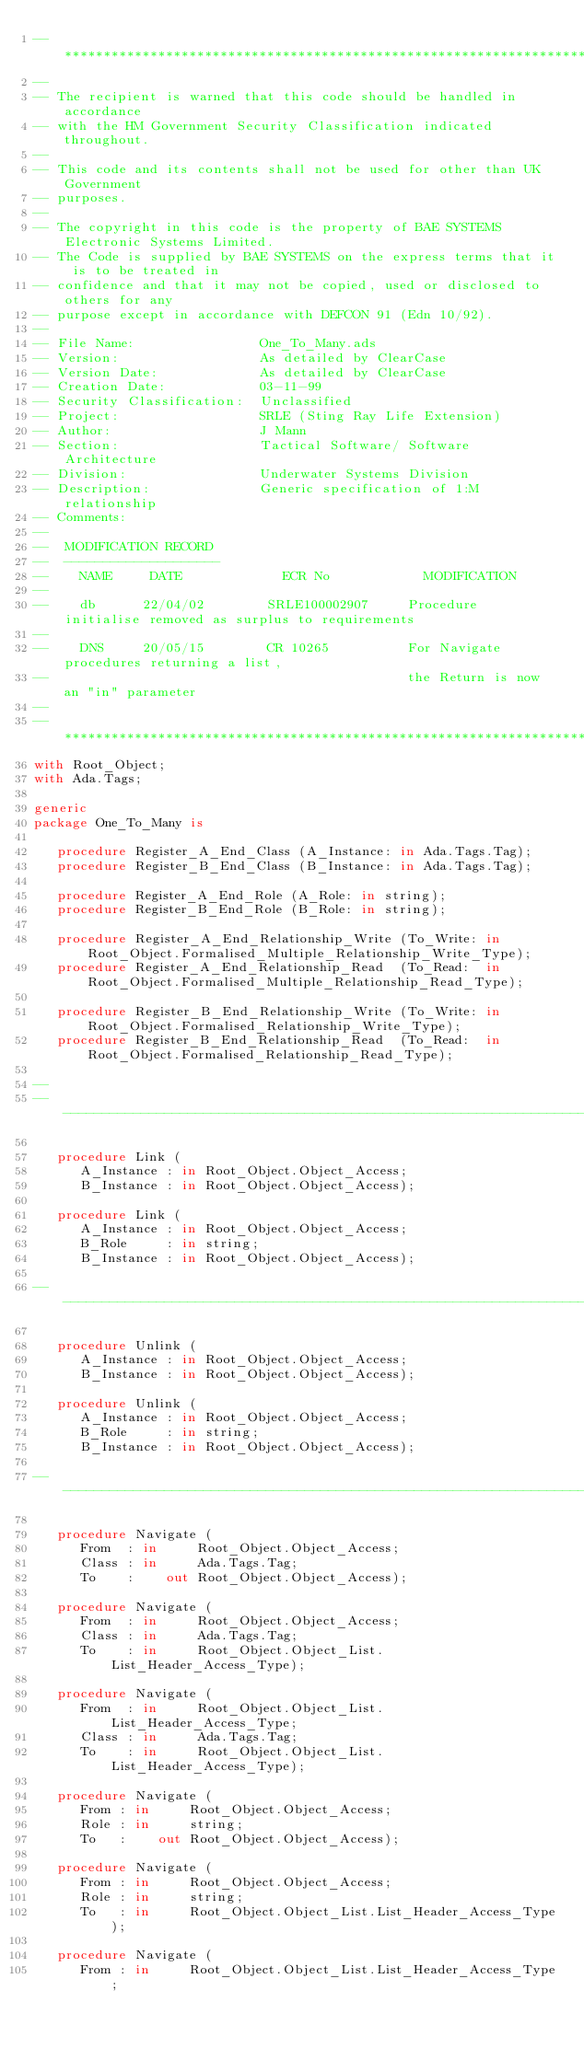<code> <loc_0><loc_0><loc_500><loc_500><_Ada_>-- *************************************************************************************
--
-- The recipient is warned that this code should be handled in accordance
-- with the HM Government Security Classification indicated throughout.
--
-- This code and its contents shall not be used for other than UK Government
-- purposes.
--
-- The copyright in this code is the property of BAE SYSTEMS Electronic Systems Limited.
-- The Code is supplied by BAE SYSTEMS on the express terms that it is to be treated in
-- confidence and that it may not be copied, used or disclosed to others for any
-- purpose except in accordance with DEFCON 91 (Edn 10/92).
--
-- File Name:                One_To_Many.ads
-- Version:                  As detailed by ClearCase
-- Version Date:             As detailed by ClearCase
-- Creation Date:            03-11-99
-- Security Classification:  Unclassified
-- Project:                  SRLE (Sting Ray Life Extension)
-- Author:                   J Mann
-- Section:                  Tactical Software/ Software Architecture
-- Division:                 Underwater Systems Division
-- Description:              Generic specification of 1:M relationship
-- Comments:
--
--  MODIFICATION RECORD
--  --------------------
--    NAME     DATE             ECR No            MODIFICATION
--
--    db      22/04/02        SRLE100002907     Procedure initialise removed as surplus to requirements
--
--    DNS     20/05/15        CR 10265          For Navigate procedures returning a list,
--                                              the Return is now an "in" parameter
--
-- **************************************************************************************
with Root_Object;
with Ada.Tags;

generic
package One_To_Many is

   procedure Register_A_End_Class (A_Instance: in Ada.Tags.Tag);
   procedure Register_B_End_Class (B_Instance: in Ada.Tags.Tag);

   procedure Register_A_End_Role (A_Role: in string);
   procedure Register_B_End_Role (B_Role: in string);

   procedure Register_A_End_Relationship_Write (To_Write: in Root_Object.Formalised_Multiple_Relationship_Write_Type);
   procedure Register_A_End_Relationship_Read  (To_Read:  in Root_Object.Formalised_Multiple_Relationship_Read_Type);

   procedure Register_B_End_Relationship_Write (To_Write: in Root_Object.Formalised_Relationship_Write_Type);
   procedure Register_B_End_Relationship_Read  (To_Read:  in Root_Object.Formalised_Relationship_Read_Type);

--
------------------------------------------------------------------------------------------------------

   procedure Link (
      A_Instance : in Root_Object.Object_Access;
      B_Instance : in Root_Object.Object_Access);

   procedure Link (
      A_Instance : in Root_Object.Object_Access;
      B_Role     : in string;
      B_Instance : in Root_Object.Object_Access);

------------------------------------------------------------------------------------------------------

   procedure Unlink (
      A_Instance : in Root_Object.Object_Access;
      B_Instance : in Root_Object.Object_Access);

   procedure Unlink (
      A_Instance : in Root_Object.Object_Access;
      B_Role     : in string;
      B_Instance : in Root_Object.Object_Access);

------------------------------------------------------------------------------------------------------

   procedure Navigate (
      From  : in     Root_Object.Object_Access;
      Class : in     Ada.Tags.Tag;
      To    :    out Root_Object.Object_Access);

   procedure Navigate (
      From  : in     Root_Object.Object_Access;
      Class : in     Ada.Tags.Tag;
      To    : in     Root_Object.Object_List.List_Header_Access_Type);

   procedure Navigate (
      From  : in     Root_Object.Object_List.List_Header_Access_Type;
      Class : in     Ada.Tags.Tag;
      To    : in     Root_Object.Object_List.List_Header_Access_Type);

   procedure Navigate (
      From : in     Root_Object.Object_Access;
      Role : in     string;
      To   :    out Root_Object.Object_Access);

   procedure Navigate (
      From : in     Root_Object.Object_Access;
      Role : in     string;
      To   : in     Root_Object.Object_List.List_Header_Access_Type);

   procedure Navigate (
      From : in     Root_Object.Object_List.List_Header_Access_Type;</code> 